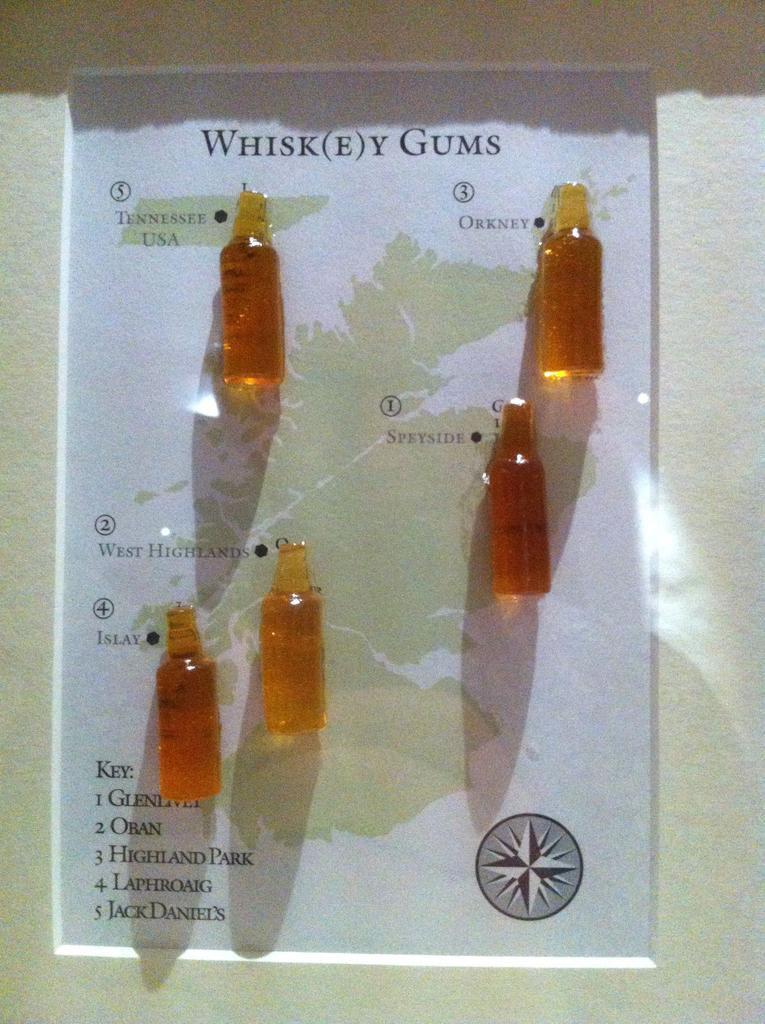What type of objects can be seen in the image? There are small bottles in the image. How many ants are crawling on the bottles in the image? There are no ants present in the image; it only features small bottles. What type of connection is visible between the bottles in the image? There is no connection between the bottles visible in the image. 